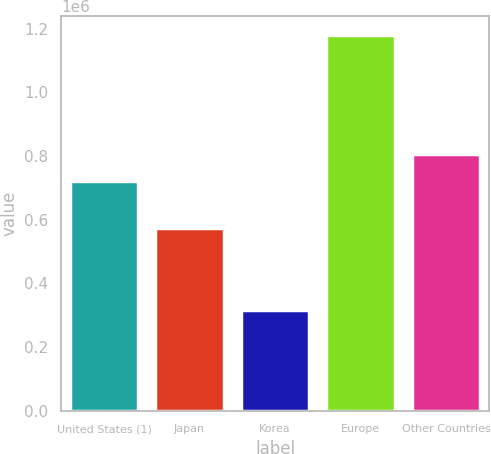Convert chart. <chart><loc_0><loc_0><loc_500><loc_500><bar_chart><fcel>United States (1)<fcel>Japan<fcel>Korea<fcel>Europe<fcel>Other Countries<nl><fcel>720679<fcel>575479<fcel>316893<fcel>1.17947e+06<fcel>806937<nl></chart> 